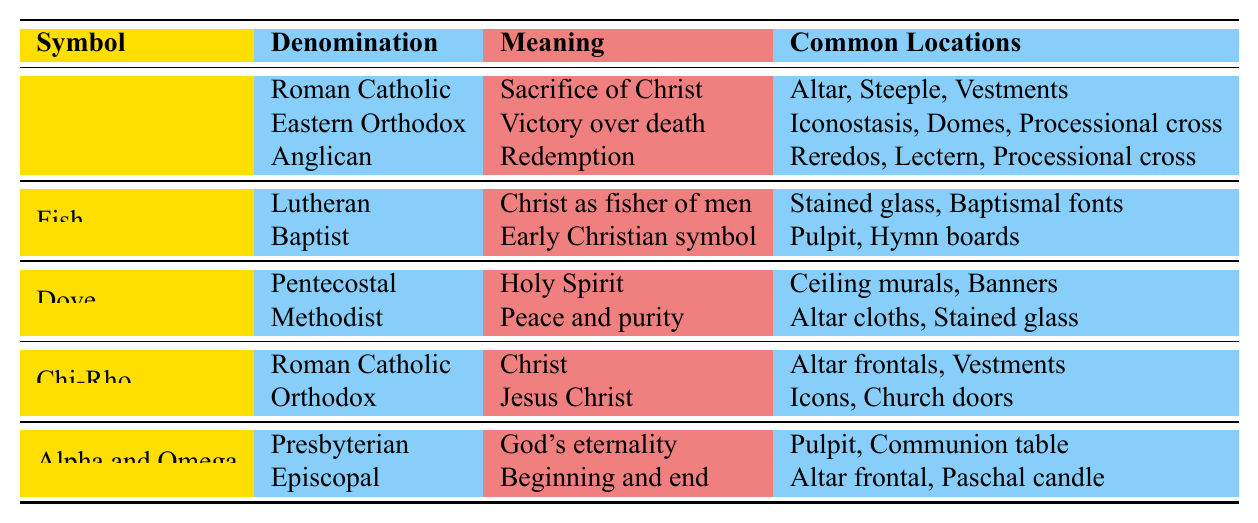What does the symbol 'Cross' represent in Roman Catholicism? According to the table, the 'Cross' represents the "Sacrifice of Christ" in Roman Catholicism.
Answer: Sacrifice of Christ In which locations is the 'Fish' symbol commonly found in the Baptist denomination? The table indicates that the 'Fish' symbol is commonly found in the "Pulpit" and "Hymn boards" for the Baptist denomination.
Answer: Pulpit, Hymn boards How many meanings are associated with the 'Dove' symbol? The table shows that there are two meanings associated with the 'Dove' symbol: "Holy Spirit" for Pentecostal and "Peace and purity" for Methodist.
Answer: 2 Which denominations associate the 'Chi-Rho' symbol with Christ? Both Roman Catholic and Orthodox denominations associate the 'Chi-Rho' symbol with Christ, representing it as "Christ" and "Jesus Christ" respectively.
Answer: Roman Catholic, Orthodox Is the 'Alpha and Omega' symbol linked to God's eternality in the Presbyterian denomination? Yes, the table confirms that the 'Alpha and Omega' symbol represents "God's eternality" in the Presbyterian denomination.
Answer: Yes What are the common locations for the 'Dove' symbol in the Pentecostal denomination? In the table, the common locations for the 'Dove' symbol in the Pentecostal denomination are "Ceiling murals" and "Banners".
Answer: Ceiling murals, Banners Which symbol is associated with the concept of "Victory over death"? The table shows that the 'Cross' symbol is associated with the meaning of "Victory over death" in the Eastern Orthodox denomination.
Answer: Cross How many total denominations reference the 'Cross' symbol? The table lists three denominations that reference the 'Cross' symbol: Roman Catholic, Eastern Orthodox, and Anglican.
Answer: 3 Are 'Altar frontals' associated with the 'Chi-Rho' symbol? Yes, the table indicates that 'Altar frontals' are listed as one of the common locations for the 'Chi-Rho' symbol, particularly in Roman Catholicism.
Answer: Yes In how many instances is the 'Alpha and Omega' symbol mentioned, and what are its meanings? The 'Alpha and Omega' symbol appears twice in the table; it means "God's eternality" in Presbyterian and "Beginning and end" in Episcopal.
Answer: 2, God's eternality; Beginning and end 